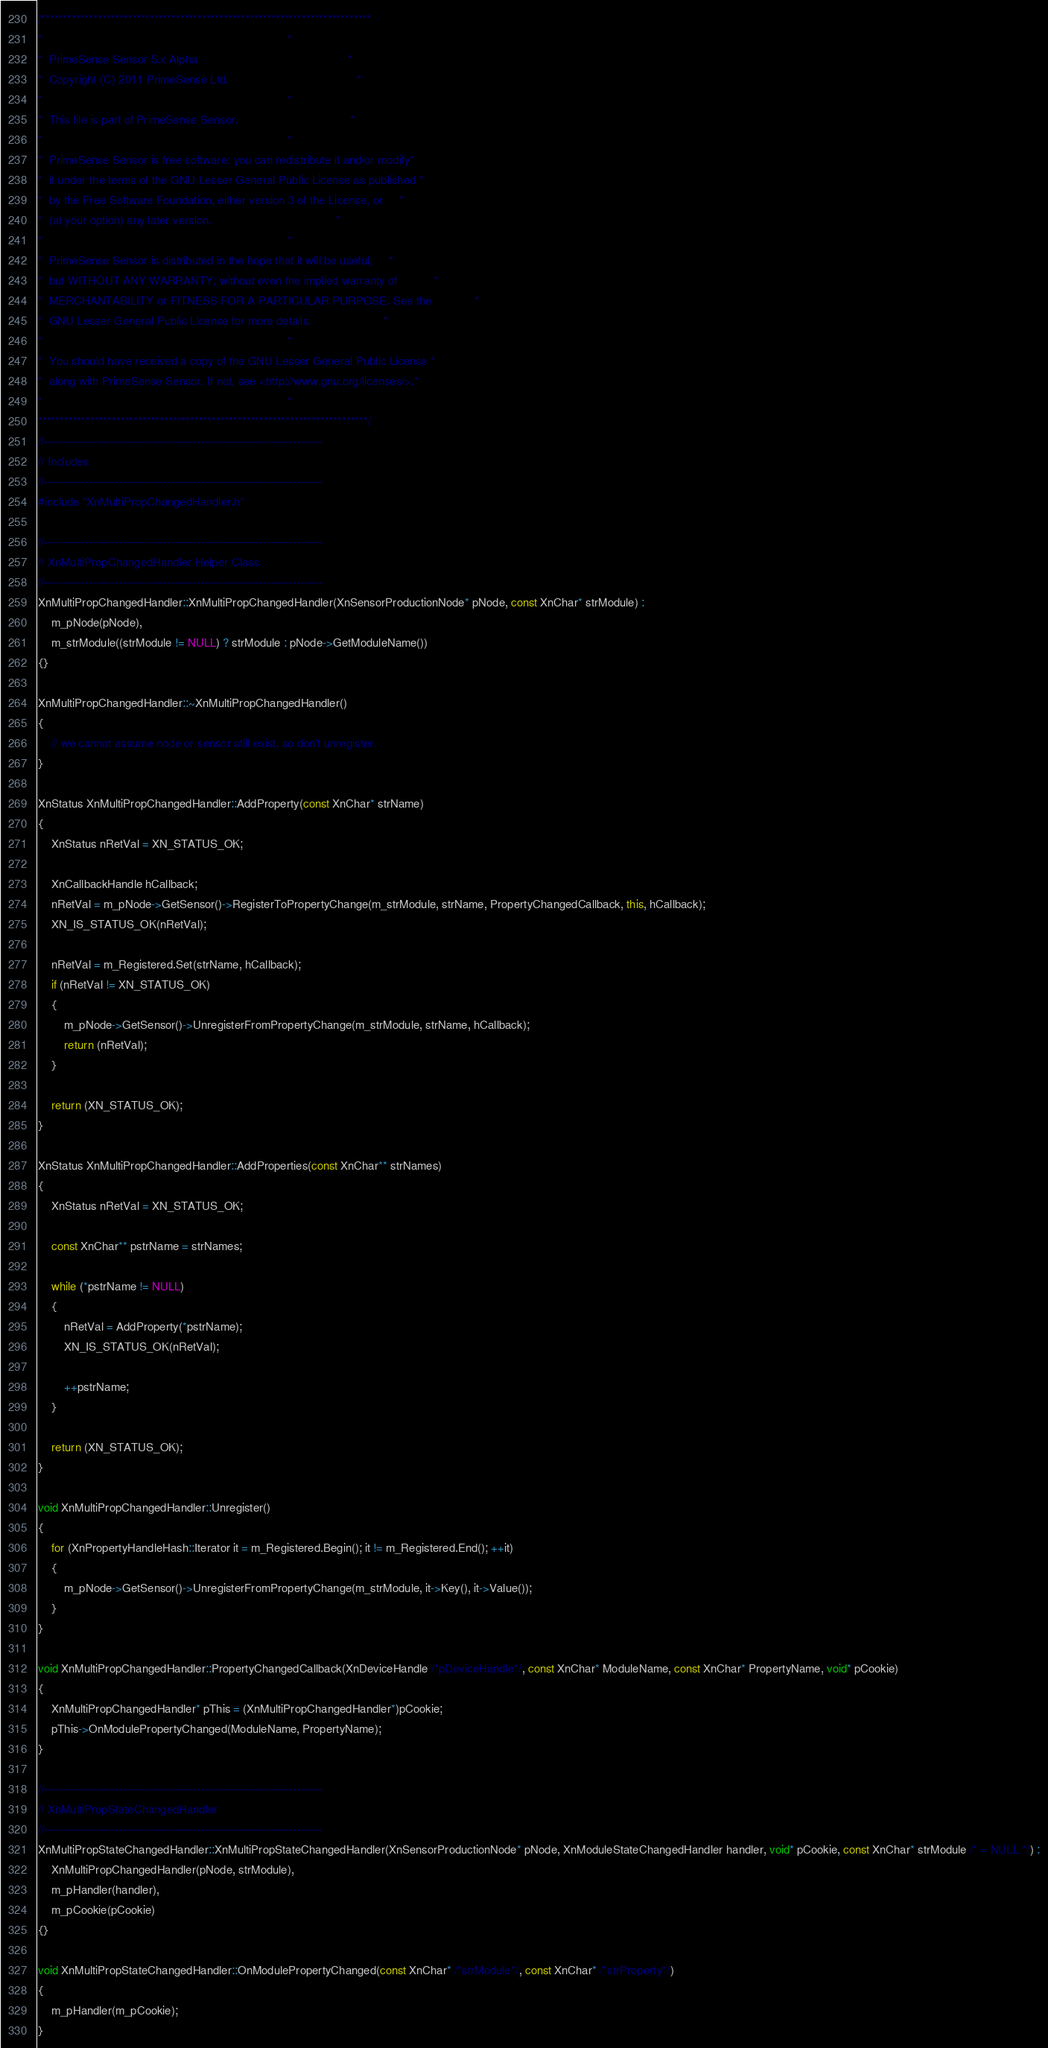Convert code to text. <code><loc_0><loc_0><loc_500><loc_500><_C++_>/****************************************************************************
*                                                                           *
*  PrimeSense Sensor 5.x Alpha                                              *
*  Copyright (C) 2011 PrimeSense Ltd.                                       *
*                                                                           *
*  This file is part of PrimeSense Sensor.                                  *
*                                                                           *
*  PrimeSense Sensor is free software: you can redistribute it and/or modify*
*  it under the terms of the GNU Lesser General Public License as published *
*  by the Free Software Foundation, either version 3 of the License, or     *
*  (at your option) any later version.                                      *
*                                                                           *
*  PrimeSense Sensor is distributed in the hope that it will be useful,     *
*  but WITHOUT ANY WARRANTY; without even the implied warranty of           *
*  MERCHANTABILITY or FITNESS FOR A PARTICULAR PURPOSE. See the             *
*  GNU Lesser General Public License for more details.                      *
*                                                                           *
*  You should have received a copy of the GNU Lesser General Public License *
*  along with PrimeSense Sensor. If not, see <http://www.gnu.org/licenses/>.*
*                                                                           *
****************************************************************************/
//---------------------------------------------------------------------------
// Includes
//---------------------------------------------------------------------------
#include "XnMultiPropChangedHandler.h"

//---------------------------------------------------------------------------
// XnMultiPropChangedHandler Helper Class
//---------------------------------------------------------------------------
XnMultiPropChangedHandler::XnMultiPropChangedHandler(XnSensorProductionNode* pNode, const XnChar* strModule) :
	m_pNode(pNode), 
	m_strModule((strModule != NULL) ? strModule : pNode->GetModuleName())
{}

XnMultiPropChangedHandler::~XnMultiPropChangedHandler()
{
	// we cannot assume node or sensor still exist, so don't unregister.
}

XnStatus XnMultiPropChangedHandler::AddProperty(const XnChar* strName)
{
	XnStatus nRetVal = XN_STATUS_OK;

	XnCallbackHandle hCallback;
	nRetVal = m_pNode->GetSensor()->RegisterToPropertyChange(m_strModule, strName, PropertyChangedCallback, this, hCallback);
	XN_IS_STATUS_OK(nRetVal);

	nRetVal = m_Registered.Set(strName, hCallback);
	if (nRetVal != XN_STATUS_OK)
	{
		m_pNode->GetSensor()->UnregisterFromPropertyChange(m_strModule, strName, hCallback);
		return (nRetVal);
	}

	return (XN_STATUS_OK);
}

XnStatus XnMultiPropChangedHandler::AddProperties(const XnChar** strNames)
{
	XnStatus nRetVal = XN_STATUS_OK;

	const XnChar** pstrName = strNames;

	while (*pstrName != NULL)
	{
		nRetVal = AddProperty(*pstrName);
		XN_IS_STATUS_OK(nRetVal);

		++pstrName;
	}

	return (XN_STATUS_OK);
}

void XnMultiPropChangedHandler::Unregister()
{
	for (XnPropertyHandleHash::Iterator it = m_Registered.Begin(); it != m_Registered.End(); ++it)
	{
		m_pNode->GetSensor()->UnregisterFromPropertyChange(m_strModule, it->Key(), it->Value());
	}
}

void XnMultiPropChangedHandler::PropertyChangedCallback(XnDeviceHandle /*pDeviceHandle*/, const XnChar* ModuleName, const XnChar* PropertyName, void* pCookie)
{
	XnMultiPropChangedHandler* pThis = (XnMultiPropChangedHandler*)pCookie;
	pThis->OnModulePropertyChanged(ModuleName, PropertyName);
}

//---------------------------------------------------------------------------
// XnMultiPropStateChangedHandler
//---------------------------------------------------------------------------
XnMultiPropStateChangedHandler::XnMultiPropStateChangedHandler(XnSensorProductionNode* pNode, XnModuleStateChangedHandler handler, void* pCookie, const XnChar* strModule /* = NULL */) :
	XnMultiPropChangedHandler(pNode, strModule),
	m_pHandler(handler), 
	m_pCookie(pCookie)
{}

void XnMultiPropStateChangedHandler::OnModulePropertyChanged(const XnChar* /*strModule*/, const XnChar* /*strProperty*/)
{
	m_pHandler(m_pCookie);
}

</code> 